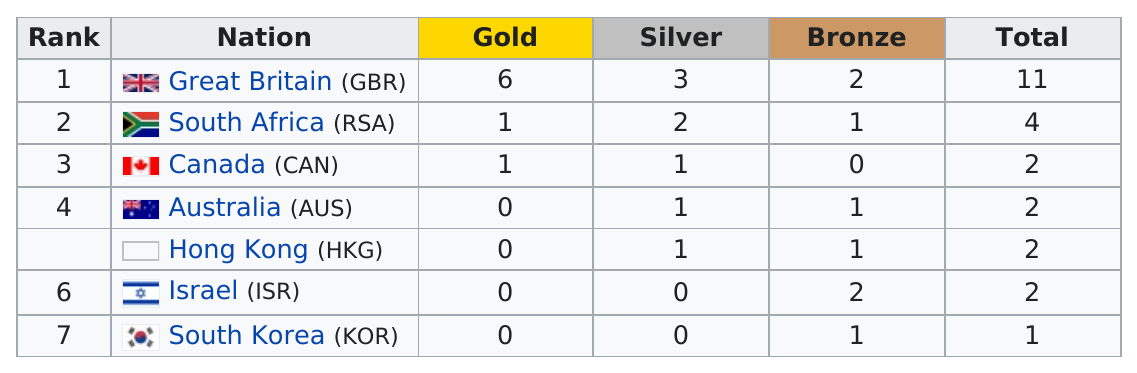Identify some key points in this picture. Israel won as many bronze medals as Great Britain, but did not win a gold medal. The country with the most medals won more medals than the country with the fewest medals. Great Britain won the most silver medals in the country. Great Britain won the most medals among all countries. In the Olympic Games, Great Britain or Hong Kong had a higher ratio of silver to bronze medals. 